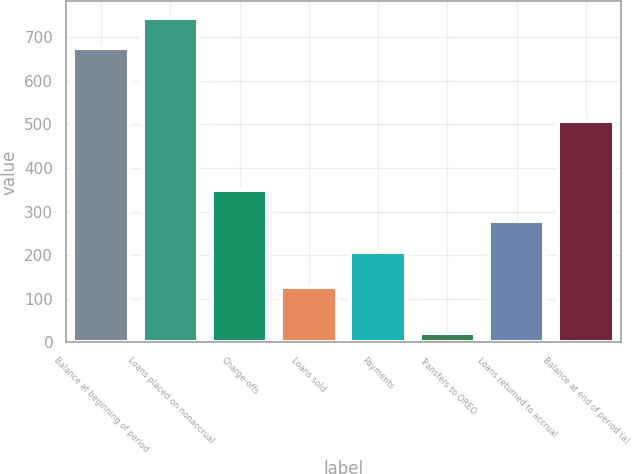Convert chart. <chart><loc_0><loc_0><loc_500><loc_500><bar_chart><fcel>Balance at beginning of period<fcel>Loans placed on nonaccrual<fcel>Charge-offs<fcel>Loans sold<fcel>Payments<fcel>Transfers to OREO<fcel>Loans returned to accrual<fcel>Balance at end of period (a)<nl><fcel>674<fcel>744.7<fcel>349.4<fcel>127<fcel>208<fcel>21<fcel>278.7<fcel>508<nl></chart> 